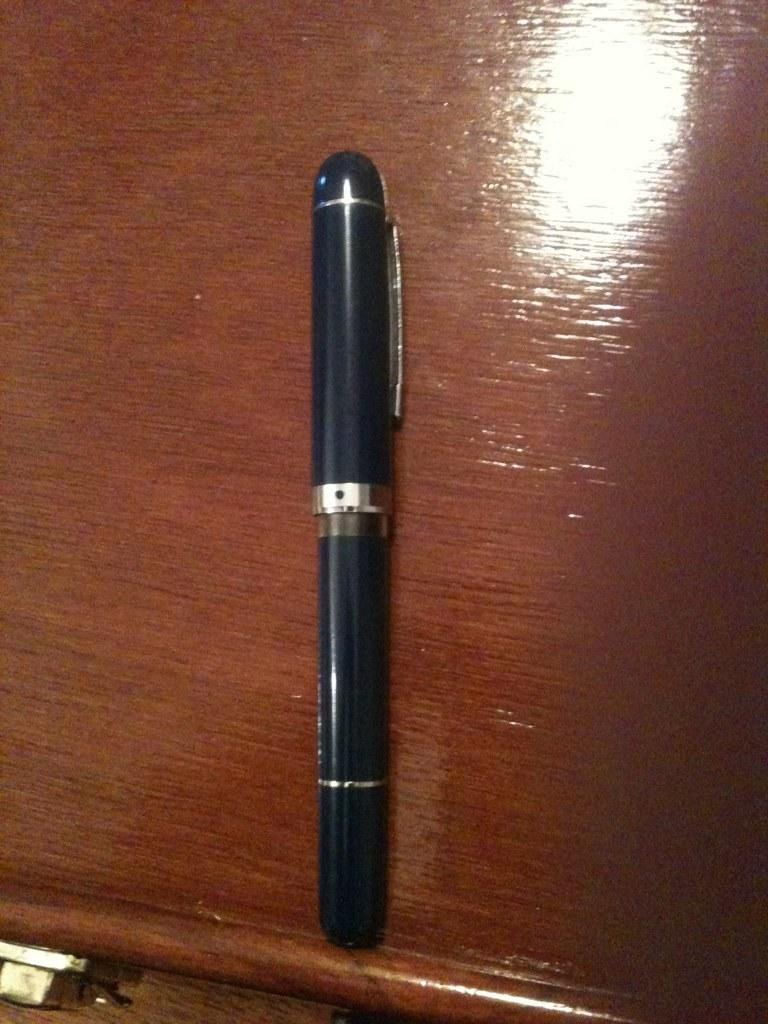What type of writing instrument is in the image? There is a navy blue color pen in the image. What color is the pen? The pen is navy blue. What is the pen placed on in the image? The pen is on a brown color surface. What can be inferred about the material of the surface based on its color? The surface may be made of wood or a similar material, given its brown color. How many geese are flying in the rainstorm in the image? There are no geese or rainstorm present in the image; it only features a navy blue pen on a brown surface. 